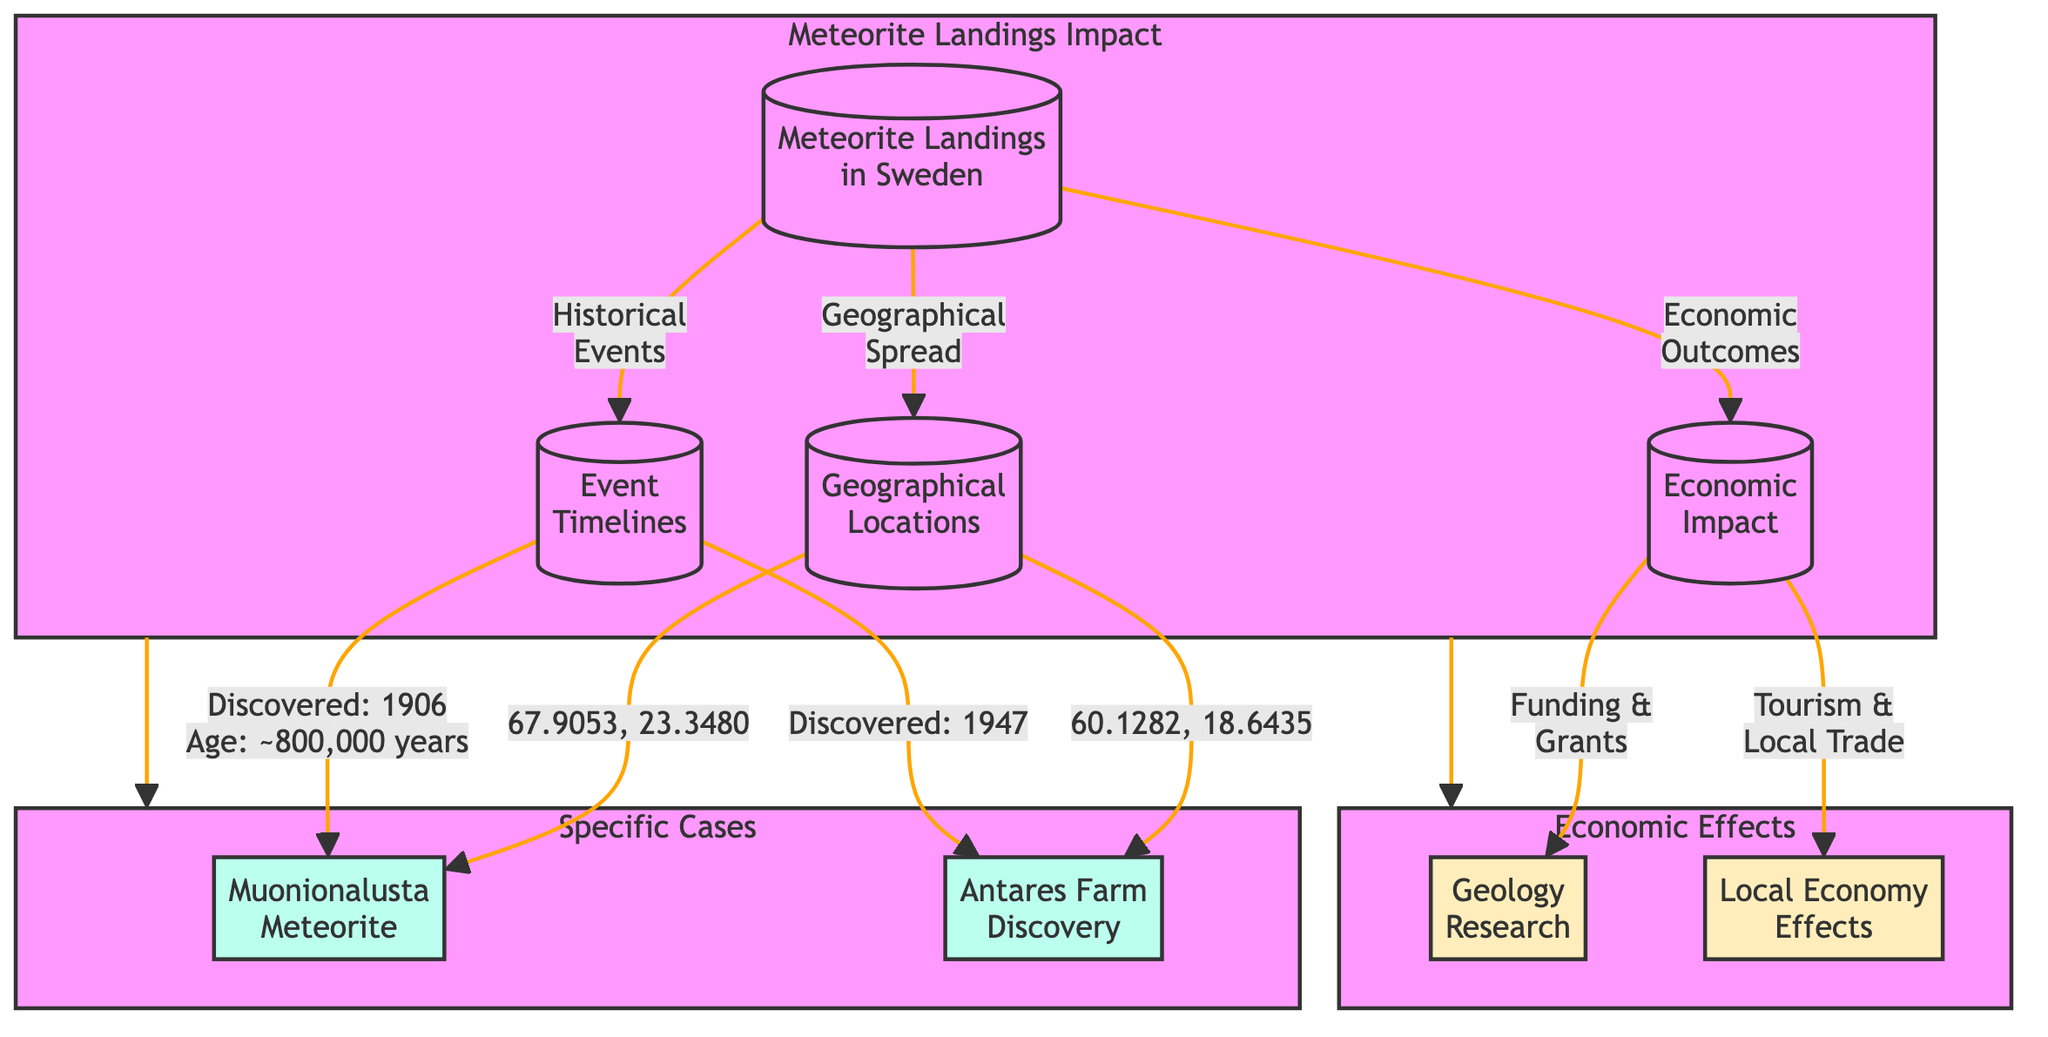What is the geographical location of the Muonionalusta meteorite? The diagram shows the Muonionalusta meteorite linked to the geographical location with coordinates "67.9053, 23.3480."
Answer: 67.9053, 23.3480 When was the Antares Farm meteorite discovered? The diagram indicates that the Antares Farm meteorite was discovered in 1947, as shown in the event timelines section linked to that meteorite.
Answer: 1947 What type of economic outcome is associated with geology research? The diagram shows a connection from economic impact to geology research labeled "Funding & Grants," which indicates the economic outcome tied to that node.
Answer: Funding & Grants How many specific cases of meteorite landings are highlighted in the diagram? There are two specific cases identified in the diagram, represented by the nodes for Muonionalusta and Antares Farm, connected from the main meteorite landings node.
Answer: 2 What is the age of the Muonionalusta meteorite? According to the diagram, the Muonionalusta meteorite is indicated to be approximately 800,000 years old, which is specified in the event timelines.
Answer: ~800,000 years What are the local economy effects mentioned in relation to meteorite landings? The diagram states that local economy effects relate to "Tourism & Local Trade," which is connected to the economic impact section of the diagram.
Answer: Tourism & Local Trade Which geographical location corresponds to the Antares Farm meteorite? The diagram indicates that the geographical location for the Antares Farm meteorite is linked with coordinates "60.1282, 18.6435."
Answer: 60.1282, 18.6435 How does the geographical spread connect to the meteorite landings? The diagram shows a direct link from meteorite landings to geographical locations, indicating the relationship that meteorite landings have with their respective geographies.
Answer: Geographical locations What type of economic outcome directly affects local trade? The diagram shows that the link for the local economy effects leads to "Tourism & Local Trade," suggesting that is the economic outcome affected by meteorite landings.
Answer: Tourism & Local Trade 